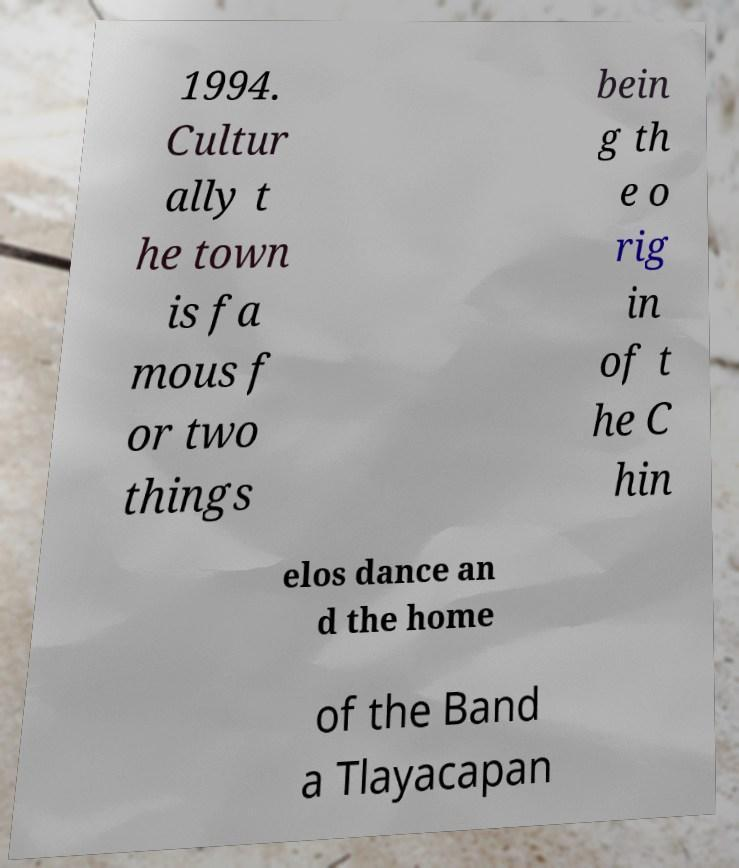Can you read and provide the text displayed in the image?This photo seems to have some interesting text. Can you extract and type it out for me? 1994. Cultur ally t he town is fa mous f or two things bein g th e o rig in of t he C hin elos dance an d the home of the Band a Tlayacapan 